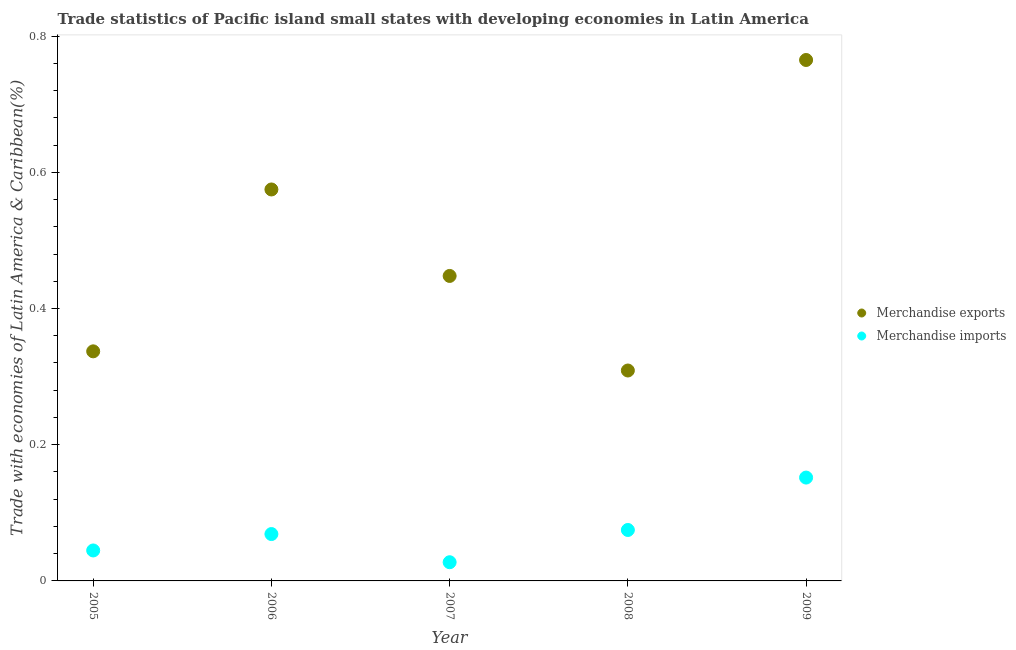How many different coloured dotlines are there?
Make the answer very short. 2. What is the merchandise exports in 2005?
Offer a very short reply. 0.34. Across all years, what is the maximum merchandise imports?
Provide a succinct answer. 0.15. Across all years, what is the minimum merchandise imports?
Make the answer very short. 0.03. What is the total merchandise imports in the graph?
Your answer should be very brief. 0.37. What is the difference between the merchandise imports in 2007 and that in 2009?
Ensure brevity in your answer.  -0.12. What is the difference between the merchandise imports in 2007 and the merchandise exports in 2009?
Your answer should be compact. -0.74. What is the average merchandise imports per year?
Your answer should be compact. 0.07. In the year 2006, what is the difference between the merchandise imports and merchandise exports?
Your response must be concise. -0.51. What is the ratio of the merchandise exports in 2005 to that in 2009?
Offer a terse response. 0.44. Is the merchandise exports in 2006 less than that in 2007?
Provide a short and direct response. No. What is the difference between the highest and the second highest merchandise imports?
Offer a very short reply. 0.08. What is the difference between the highest and the lowest merchandise imports?
Keep it short and to the point. 0.12. Is the sum of the merchandise imports in 2005 and 2006 greater than the maximum merchandise exports across all years?
Offer a very short reply. No. Does the merchandise exports monotonically increase over the years?
Provide a short and direct response. No. How many dotlines are there?
Offer a terse response. 2. What is the difference between two consecutive major ticks on the Y-axis?
Provide a succinct answer. 0.2. Are the values on the major ticks of Y-axis written in scientific E-notation?
Make the answer very short. No. Does the graph contain any zero values?
Your answer should be very brief. No. What is the title of the graph?
Your response must be concise. Trade statistics of Pacific island small states with developing economies in Latin America. Does "Death rate" appear as one of the legend labels in the graph?
Provide a succinct answer. No. What is the label or title of the X-axis?
Keep it short and to the point. Year. What is the label or title of the Y-axis?
Give a very brief answer. Trade with economies of Latin America & Caribbean(%). What is the Trade with economies of Latin America & Caribbean(%) of Merchandise exports in 2005?
Give a very brief answer. 0.34. What is the Trade with economies of Latin America & Caribbean(%) of Merchandise imports in 2005?
Your answer should be very brief. 0.04. What is the Trade with economies of Latin America & Caribbean(%) in Merchandise exports in 2006?
Provide a succinct answer. 0.57. What is the Trade with economies of Latin America & Caribbean(%) of Merchandise imports in 2006?
Your response must be concise. 0.07. What is the Trade with economies of Latin America & Caribbean(%) of Merchandise exports in 2007?
Make the answer very short. 0.45. What is the Trade with economies of Latin America & Caribbean(%) in Merchandise imports in 2007?
Your answer should be very brief. 0.03. What is the Trade with economies of Latin America & Caribbean(%) in Merchandise exports in 2008?
Your response must be concise. 0.31. What is the Trade with economies of Latin America & Caribbean(%) in Merchandise imports in 2008?
Make the answer very short. 0.07. What is the Trade with economies of Latin America & Caribbean(%) in Merchandise exports in 2009?
Your response must be concise. 0.76. What is the Trade with economies of Latin America & Caribbean(%) of Merchandise imports in 2009?
Make the answer very short. 0.15. Across all years, what is the maximum Trade with economies of Latin America & Caribbean(%) in Merchandise exports?
Ensure brevity in your answer.  0.76. Across all years, what is the maximum Trade with economies of Latin America & Caribbean(%) of Merchandise imports?
Your answer should be compact. 0.15. Across all years, what is the minimum Trade with economies of Latin America & Caribbean(%) in Merchandise exports?
Keep it short and to the point. 0.31. Across all years, what is the minimum Trade with economies of Latin America & Caribbean(%) of Merchandise imports?
Ensure brevity in your answer.  0.03. What is the total Trade with economies of Latin America & Caribbean(%) in Merchandise exports in the graph?
Provide a short and direct response. 2.43. What is the total Trade with economies of Latin America & Caribbean(%) of Merchandise imports in the graph?
Offer a very short reply. 0.37. What is the difference between the Trade with economies of Latin America & Caribbean(%) of Merchandise exports in 2005 and that in 2006?
Provide a short and direct response. -0.24. What is the difference between the Trade with economies of Latin America & Caribbean(%) of Merchandise imports in 2005 and that in 2006?
Your answer should be compact. -0.02. What is the difference between the Trade with economies of Latin America & Caribbean(%) of Merchandise exports in 2005 and that in 2007?
Your answer should be compact. -0.11. What is the difference between the Trade with economies of Latin America & Caribbean(%) of Merchandise imports in 2005 and that in 2007?
Keep it short and to the point. 0.02. What is the difference between the Trade with economies of Latin America & Caribbean(%) of Merchandise exports in 2005 and that in 2008?
Provide a succinct answer. 0.03. What is the difference between the Trade with economies of Latin America & Caribbean(%) of Merchandise imports in 2005 and that in 2008?
Offer a terse response. -0.03. What is the difference between the Trade with economies of Latin America & Caribbean(%) in Merchandise exports in 2005 and that in 2009?
Offer a terse response. -0.43. What is the difference between the Trade with economies of Latin America & Caribbean(%) of Merchandise imports in 2005 and that in 2009?
Your answer should be very brief. -0.11. What is the difference between the Trade with economies of Latin America & Caribbean(%) of Merchandise exports in 2006 and that in 2007?
Provide a succinct answer. 0.13. What is the difference between the Trade with economies of Latin America & Caribbean(%) in Merchandise imports in 2006 and that in 2007?
Your response must be concise. 0.04. What is the difference between the Trade with economies of Latin America & Caribbean(%) in Merchandise exports in 2006 and that in 2008?
Make the answer very short. 0.27. What is the difference between the Trade with economies of Latin America & Caribbean(%) in Merchandise imports in 2006 and that in 2008?
Your response must be concise. -0.01. What is the difference between the Trade with economies of Latin America & Caribbean(%) of Merchandise exports in 2006 and that in 2009?
Offer a very short reply. -0.19. What is the difference between the Trade with economies of Latin America & Caribbean(%) in Merchandise imports in 2006 and that in 2009?
Ensure brevity in your answer.  -0.08. What is the difference between the Trade with economies of Latin America & Caribbean(%) in Merchandise exports in 2007 and that in 2008?
Ensure brevity in your answer.  0.14. What is the difference between the Trade with economies of Latin America & Caribbean(%) of Merchandise imports in 2007 and that in 2008?
Provide a succinct answer. -0.05. What is the difference between the Trade with economies of Latin America & Caribbean(%) of Merchandise exports in 2007 and that in 2009?
Give a very brief answer. -0.32. What is the difference between the Trade with economies of Latin America & Caribbean(%) of Merchandise imports in 2007 and that in 2009?
Make the answer very short. -0.12. What is the difference between the Trade with economies of Latin America & Caribbean(%) in Merchandise exports in 2008 and that in 2009?
Ensure brevity in your answer.  -0.46. What is the difference between the Trade with economies of Latin America & Caribbean(%) of Merchandise imports in 2008 and that in 2009?
Your response must be concise. -0.08. What is the difference between the Trade with economies of Latin America & Caribbean(%) in Merchandise exports in 2005 and the Trade with economies of Latin America & Caribbean(%) in Merchandise imports in 2006?
Your response must be concise. 0.27. What is the difference between the Trade with economies of Latin America & Caribbean(%) in Merchandise exports in 2005 and the Trade with economies of Latin America & Caribbean(%) in Merchandise imports in 2007?
Your answer should be compact. 0.31. What is the difference between the Trade with economies of Latin America & Caribbean(%) of Merchandise exports in 2005 and the Trade with economies of Latin America & Caribbean(%) of Merchandise imports in 2008?
Make the answer very short. 0.26. What is the difference between the Trade with economies of Latin America & Caribbean(%) in Merchandise exports in 2005 and the Trade with economies of Latin America & Caribbean(%) in Merchandise imports in 2009?
Provide a succinct answer. 0.19. What is the difference between the Trade with economies of Latin America & Caribbean(%) in Merchandise exports in 2006 and the Trade with economies of Latin America & Caribbean(%) in Merchandise imports in 2007?
Ensure brevity in your answer.  0.55. What is the difference between the Trade with economies of Latin America & Caribbean(%) in Merchandise exports in 2006 and the Trade with economies of Latin America & Caribbean(%) in Merchandise imports in 2009?
Offer a very short reply. 0.42. What is the difference between the Trade with economies of Latin America & Caribbean(%) in Merchandise exports in 2007 and the Trade with economies of Latin America & Caribbean(%) in Merchandise imports in 2008?
Your answer should be compact. 0.37. What is the difference between the Trade with economies of Latin America & Caribbean(%) of Merchandise exports in 2007 and the Trade with economies of Latin America & Caribbean(%) of Merchandise imports in 2009?
Ensure brevity in your answer.  0.3. What is the difference between the Trade with economies of Latin America & Caribbean(%) in Merchandise exports in 2008 and the Trade with economies of Latin America & Caribbean(%) in Merchandise imports in 2009?
Give a very brief answer. 0.16. What is the average Trade with economies of Latin America & Caribbean(%) of Merchandise exports per year?
Keep it short and to the point. 0.49. What is the average Trade with economies of Latin America & Caribbean(%) in Merchandise imports per year?
Provide a succinct answer. 0.07. In the year 2005, what is the difference between the Trade with economies of Latin America & Caribbean(%) of Merchandise exports and Trade with economies of Latin America & Caribbean(%) of Merchandise imports?
Make the answer very short. 0.29. In the year 2006, what is the difference between the Trade with economies of Latin America & Caribbean(%) of Merchandise exports and Trade with economies of Latin America & Caribbean(%) of Merchandise imports?
Offer a terse response. 0.51. In the year 2007, what is the difference between the Trade with economies of Latin America & Caribbean(%) in Merchandise exports and Trade with economies of Latin America & Caribbean(%) in Merchandise imports?
Your answer should be very brief. 0.42. In the year 2008, what is the difference between the Trade with economies of Latin America & Caribbean(%) of Merchandise exports and Trade with economies of Latin America & Caribbean(%) of Merchandise imports?
Give a very brief answer. 0.23. In the year 2009, what is the difference between the Trade with economies of Latin America & Caribbean(%) in Merchandise exports and Trade with economies of Latin America & Caribbean(%) in Merchandise imports?
Provide a short and direct response. 0.61. What is the ratio of the Trade with economies of Latin America & Caribbean(%) of Merchandise exports in 2005 to that in 2006?
Provide a succinct answer. 0.59. What is the ratio of the Trade with economies of Latin America & Caribbean(%) in Merchandise imports in 2005 to that in 2006?
Give a very brief answer. 0.65. What is the ratio of the Trade with economies of Latin America & Caribbean(%) in Merchandise exports in 2005 to that in 2007?
Give a very brief answer. 0.75. What is the ratio of the Trade with economies of Latin America & Caribbean(%) in Merchandise imports in 2005 to that in 2007?
Provide a short and direct response. 1.63. What is the ratio of the Trade with economies of Latin America & Caribbean(%) of Merchandise exports in 2005 to that in 2008?
Provide a succinct answer. 1.09. What is the ratio of the Trade with economies of Latin America & Caribbean(%) of Merchandise imports in 2005 to that in 2008?
Give a very brief answer. 0.6. What is the ratio of the Trade with economies of Latin America & Caribbean(%) of Merchandise exports in 2005 to that in 2009?
Make the answer very short. 0.44. What is the ratio of the Trade with economies of Latin America & Caribbean(%) of Merchandise imports in 2005 to that in 2009?
Your answer should be very brief. 0.29. What is the ratio of the Trade with economies of Latin America & Caribbean(%) of Merchandise exports in 2006 to that in 2007?
Offer a very short reply. 1.28. What is the ratio of the Trade with economies of Latin America & Caribbean(%) of Merchandise imports in 2006 to that in 2007?
Provide a short and direct response. 2.51. What is the ratio of the Trade with economies of Latin America & Caribbean(%) of Merchandise exports in 2006 to that in 2008?
Your response must be concise. 1.86. What is the ratio of the Trade with economies of Latin America & Caribbean(%) of Merchandise imports in 2006 to that in 2008?
Your response must be concise. 0.92. What is the ratio of the Trade with economies of Latin America & Caribbean(%) in Merchandise exports in 2006 to that in 2009?
Your answer should be compact. 0.75. What is the ratio of the Trade with economies of Latin America & Caribbean(%) in Merchandise imports in 2006 to that in 2009?
Make the answer very short. 0.45. What is the ratio of the Trade with economies of Latin America & Caribbean(%) in Merchandise exports in 2007 to that in 2008?
Your response must be concise. 1.45. What is the ratio of the Trade with economies of Latin America & Caribbean(%) of Merchandise imports in 2007 to that in 2008?
Give a very brief answer. 0.37. What is the ratio of the Trade with economies of Latin America & Caribbean(%) in Merchandise exports in 2007 to that in 2009?
Offer a very short reply. 0.59. What is the ratio of the Trade with economies of Latin America & Caribbean(%) of Merchandise imports in 2007 to that in 2009?
Your response must be concise. 0.18. What is the ratio of the Trade with economies of Latin America & Caribbean(%) in Merchandise exports in 2008 to that in 2009?
Offer a very short reply. 0.4. What is the ratio of the Trade with economies of Latin America & Caribbean(%) of Merchandise imports in 2008 to that in 2009?
Provide a succinct answer. 0.49. What is the difference between the highest and the second highest Trade with economies of Latin America & Caribbean(%) in Merchandise exports?
Provide a short and direct response. 0.19. What is the difference between the highest and the second highest Trade with economies of Latin America & Caribbean(%) in Merchandise imports?
Your response must be concise. 0.08. What is the difference between the highest and the lowest Trade with economies of Latin America & Caribbean(%) in Merchandise exports?
Ensure brevity in your answer.  0.46. What is the difference between the highest and the lowest Trade with economies of Latin America & Caribbean(%) of Merchandise imports?
Provide a short and direct response. 0.12. 